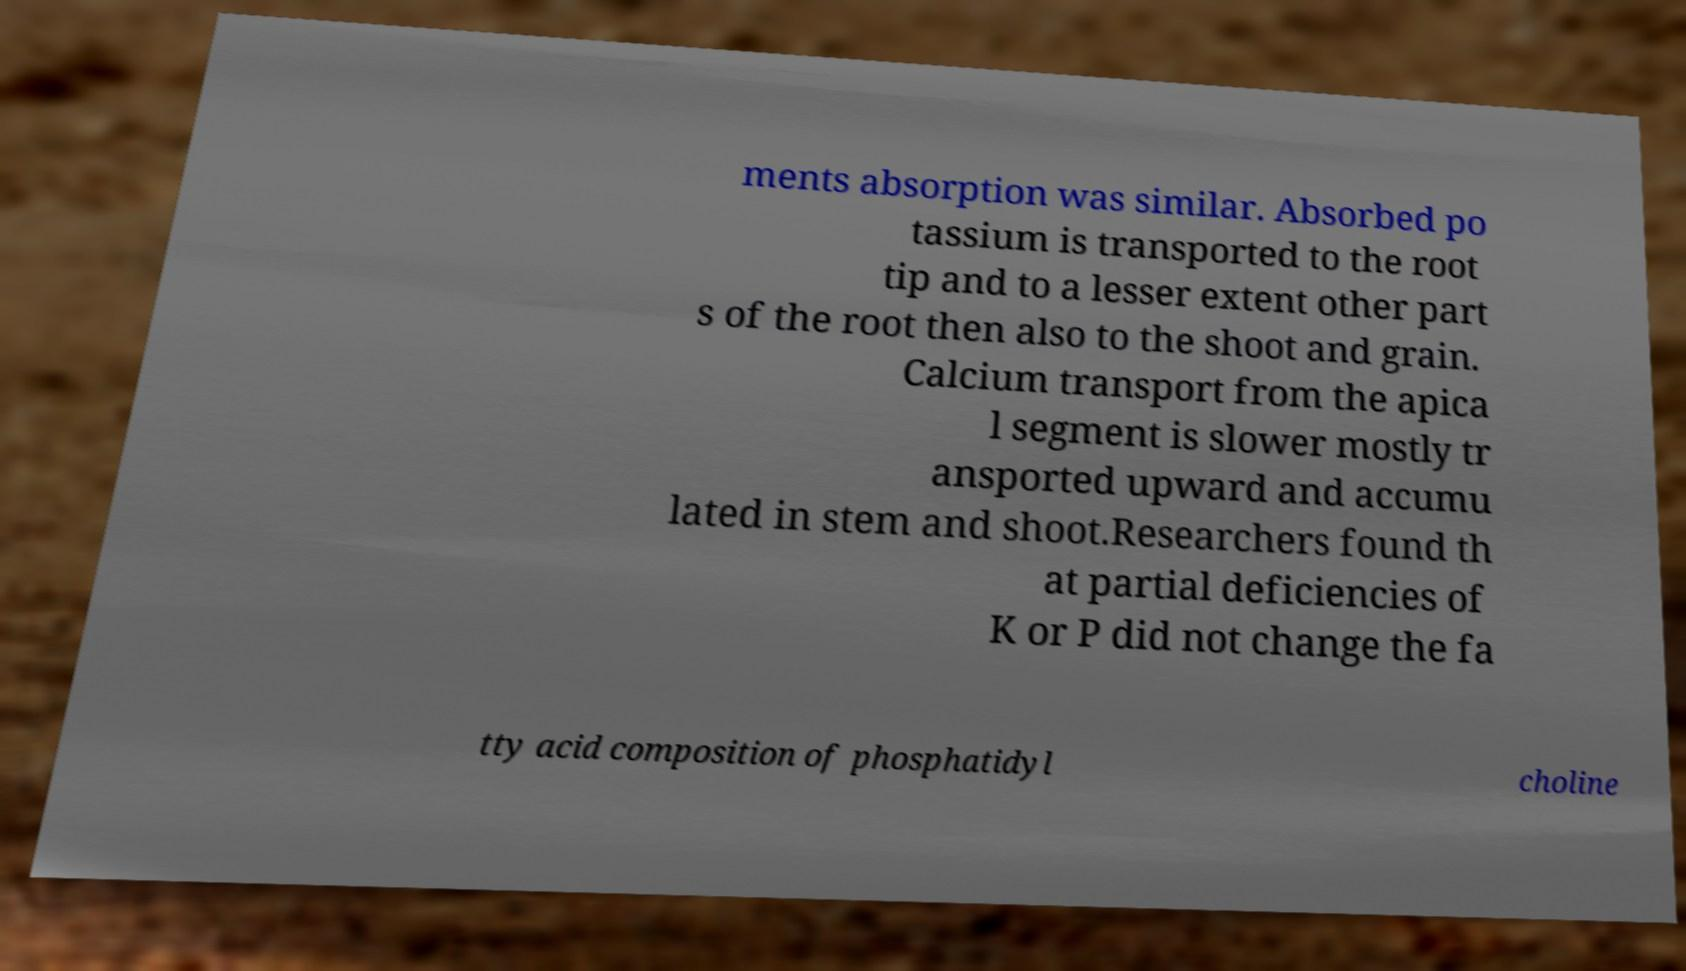Can you accurately transcribe the text from the provided image for me? ments absorption was similar. Absorbed po tassium is transported to the root tip and to a lesser extent other part s of the root then also to the shoot and grain. Calcium transport from the apica l segment is slower mostly tr ansported upward and accumu lated in stem and shoot.Researchers found th at partial deficiencies of K or P did not change the fa tty acid composition of phosphatidyl choline 